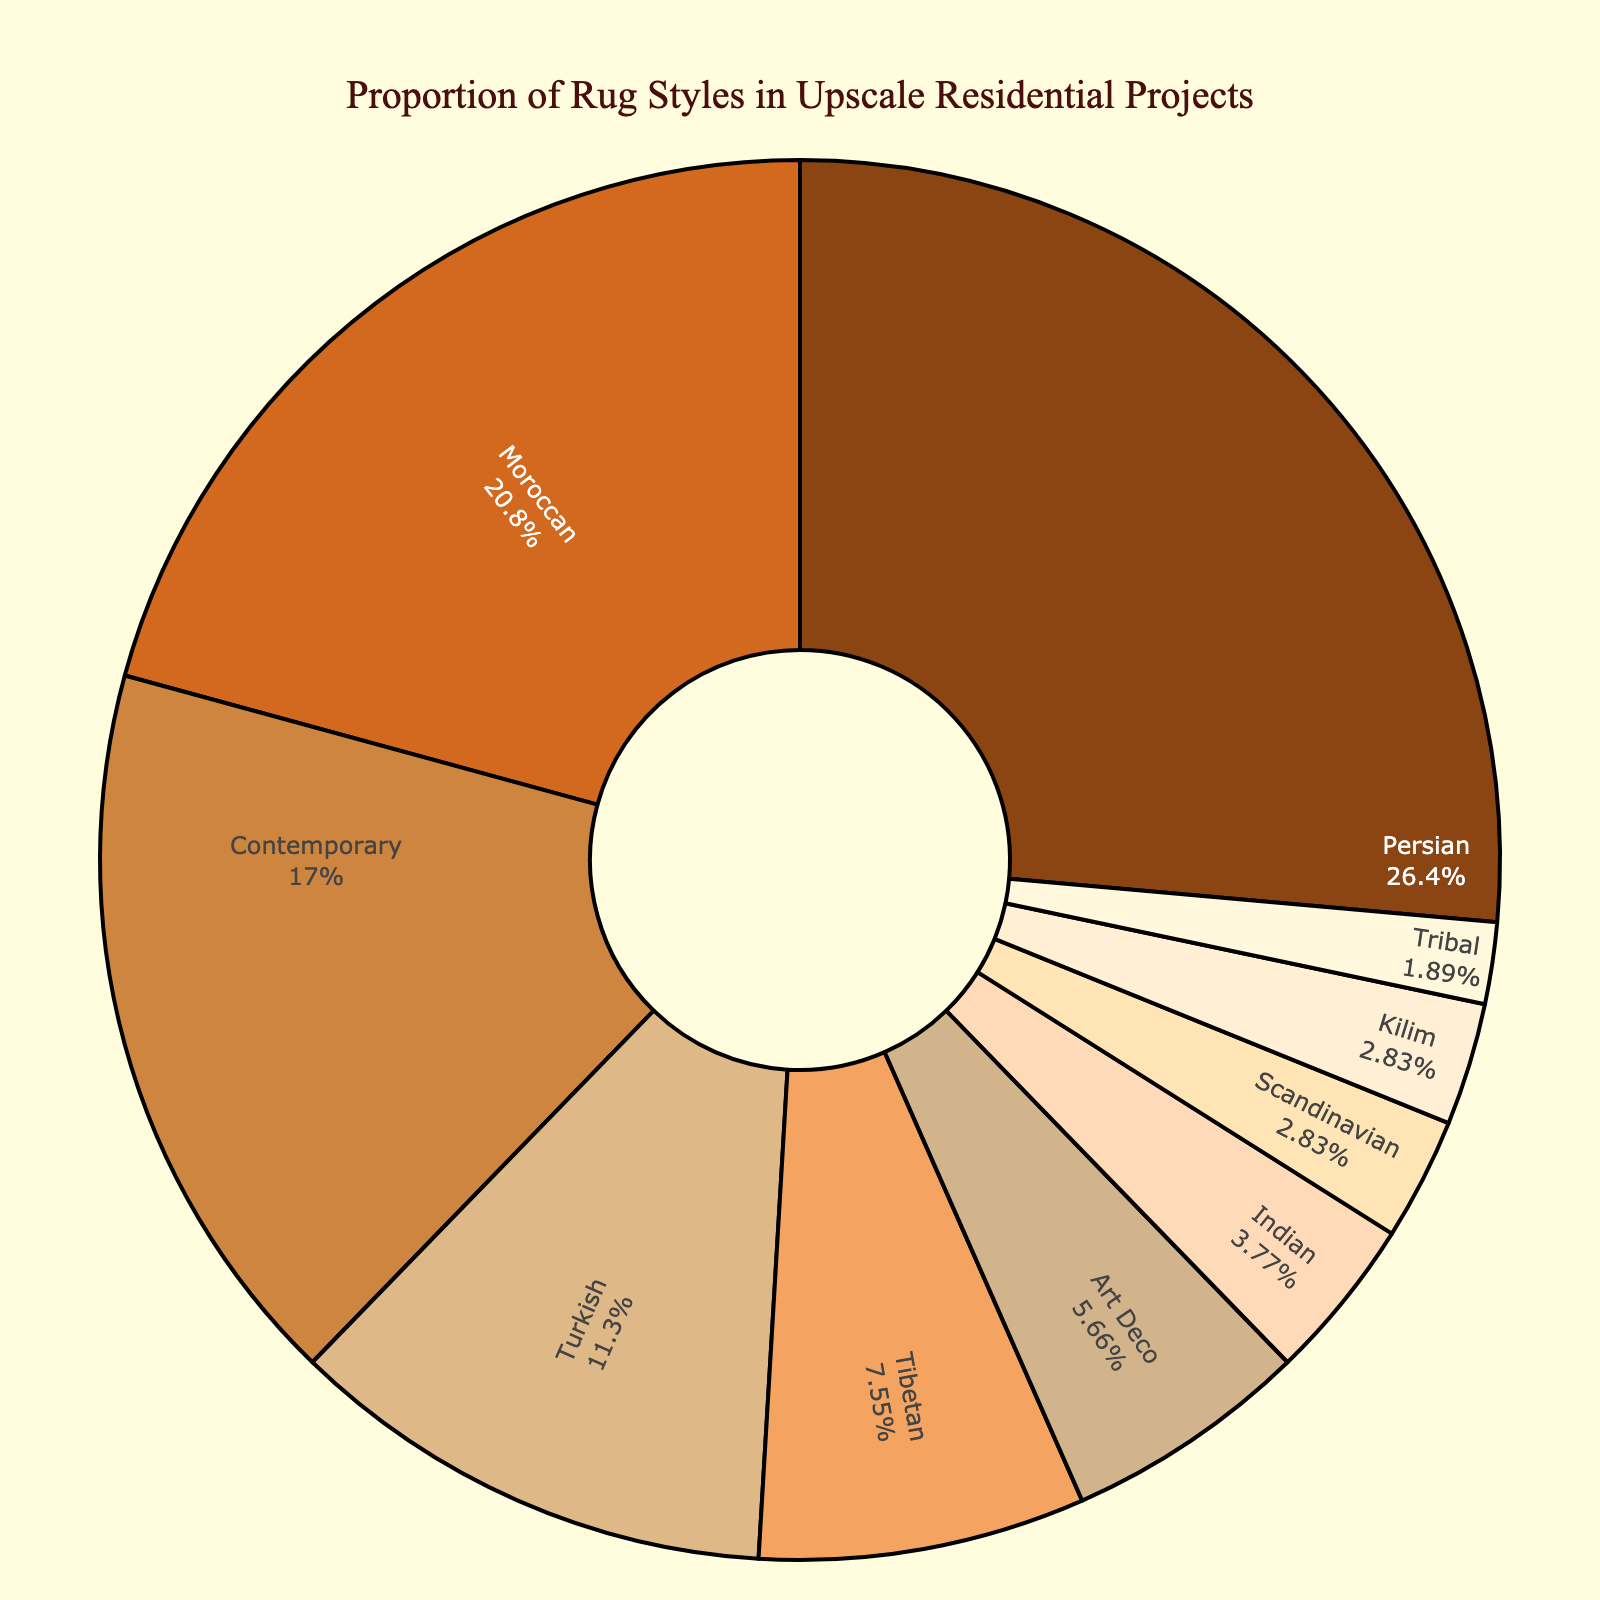Which rug style has the highest proportion? The Persian rug style slice is the largest and shows 28%.
Answer: Persian How much greater is the proportion of Persian rugs compared to Contemporary rugs? The Persian rug proportion is 28% and Contemporary is 18%. Subtracting them, 28% - 18% = 10%
Answer: 10% What is the combined percentage of Moroccan and Tibetan rug styles? Adding the percentages of Moroccan (22%) and Tibetan (8%) styles gives 22% + 8% = 30%.
Answer: 30% Which style is more prevalent, Turkish or Art Deco, and by how much? The Turkish proportion is 12% while Art Deco is 6%. Subtracting them, 12% - 6% = 6%.
Answer: Turkish by 6% How does the proportion of Art Deco rugs compare to the Scandinavian and Kilim rug styles combined? Art Deco is 6%, while Scandinavian and Kilim combined are 3% + 3% = 6%.
Answer: Equal What percentage of the rug styles are represented by the three least common styles? Adding the percentages of Indian (4%), Scandinavian (3%), and Tribal (2%) gives 4% + 3% + 2% = 9%.
Answer: 9% Visually, which rug style slice has a darker brown color, Persian or Moroccan? The Persian rug slice is a darker brown compared to the lighter brown of the Moroccan rug slice.
Answer: Persian Calculate the average percentage of the following rug styles: Tibetan, Art Deco, and Indian. Adding the percentages (8% + 6% + 4%) and dividing by 3 gives (8 + 6 + 4) / 3 = 6%.
Answer: 6% Which is more represented: Traditional (sum of Persian, Turkish, Indian) or Modern (sum of Contemporary, Art Deco, Scandinavian)? Summing Traditional (28% + 12% + 4% = 44%) and Modern (18% + 6% + 3% = 27%), Traditional is more.
Answer: Traditional Among the four most represented styles, which one has the smallest proportion? The four most represented are Persian, Moroccan, Contemporary, and Turkish. Turkish has the smallest proportion of 12%.
Answer: Turkish 